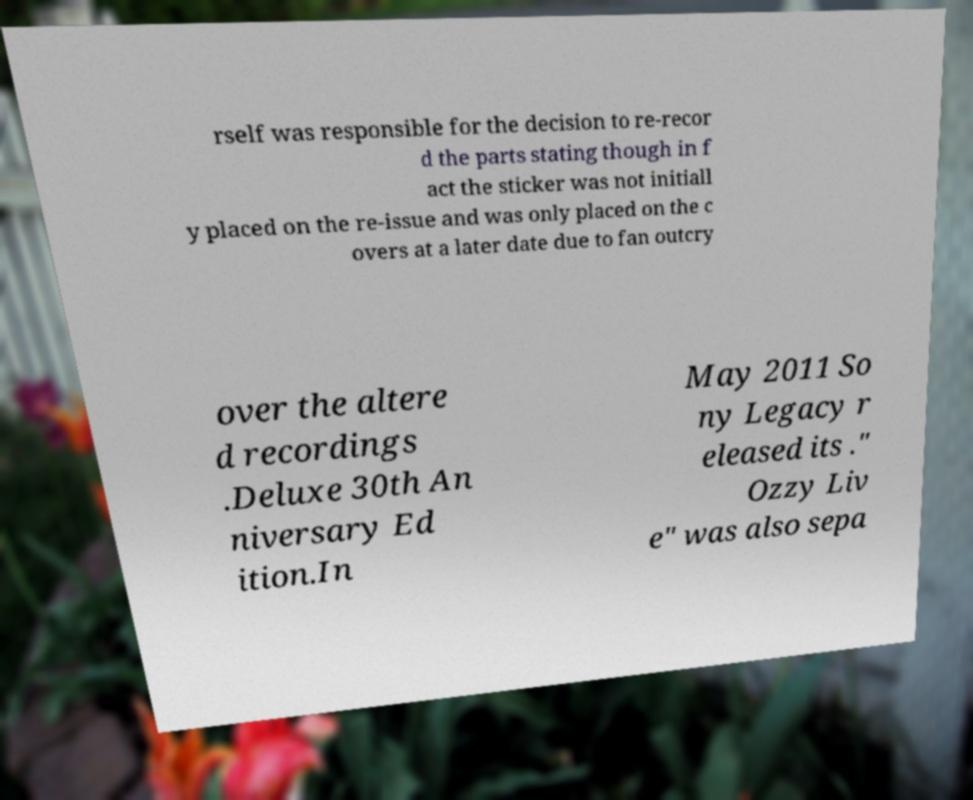Could you assist in decoding the text presented in this image and type it out clearly? rself was responsible for the decision to re-recor d the parts stating though in f act the sticker was not initiall y placed on the re-issue and was only placed on the c overs at a later date due to fan outcry over the altere d recordings .Deluxe 30th An niversary Ed ition.In May 2011 So ny Legacy r eleased its ." Ozzy Liv e" was also sepa 